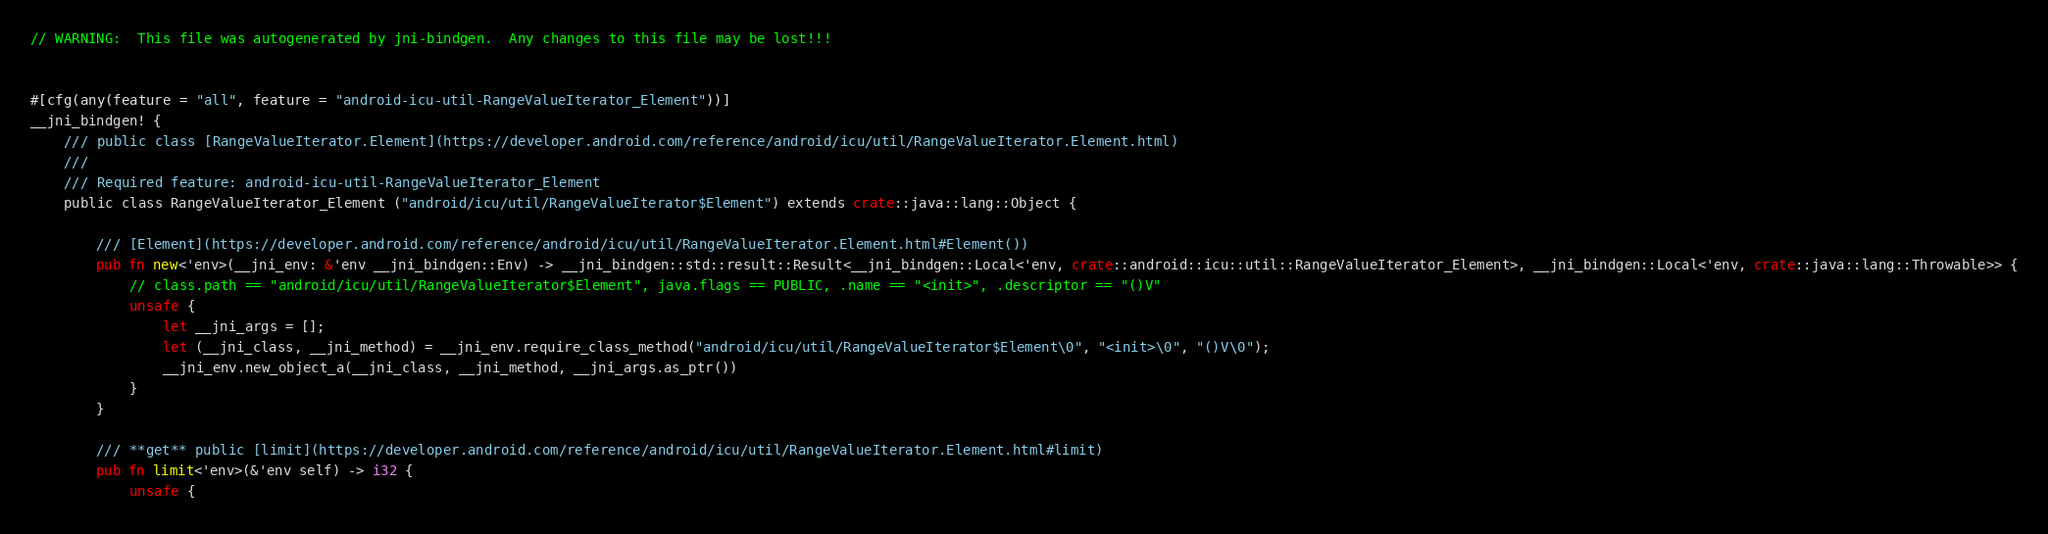<code> <loc_0><loc_0><loc_500><loc_500><_Rust_>// WARNING:  This file was autogenerated by jni-bindgen.  Any changes to this file may be lost!!!


#[cfg(any(feature = "all", feature = "android-icu-util-RangeValueIterator_Element"))]
__jni_bindgen! {
    /// public class [RangeValueIterator.Element](https://developer.android.com/reference/android/icu/util/RangeValueIterator.Element.html)
    ///
    /// Required feature: android-icu-util-RangeValueIterator_Element
    public class RangeValueIterator_Element ("android/icu/util/RangeValueIterator$Element") extends crate::java::lang::Object {

        /// [Element](https://developer.android.com/reference/android/icu/util/RangeValueIterator.Element.html#Element())
        pub fn new<'env>(__jni_env: &'env __jni_bindgen::Env) -> __jni_bindgen::std::result::Result<__jni_bindgen::Local<'env, crate::android::icu::util::RangeValueIterator_Element>, __jni_bindgen::Local<'env, crate::java::lang::Throwable>> {
            // class.path == "android/icu/util/RangeValueIterator$Element", java.flags == PUBLIC, .name == "<init>", .descriptor == "()V"
            unsafe {
                let __jni_args = [];
                let (__jni_class, __jni_method) = __jni_env.require_class_method("android/icu/util/RangeValueIterator$Element\0", "<init>\0", "()V\0");
                __jni_env.new_object_a(__jni_class, __jni_method, __jni_args.as_ptr())
            }
        }

        /// **get** public [limit](https://developer.android.com/reference/android/icu/util/RangeValueIterator.Element.html#limit)
        pub fn limit<'env>(&'env self) -> i32 {
            unsafe {</code> 